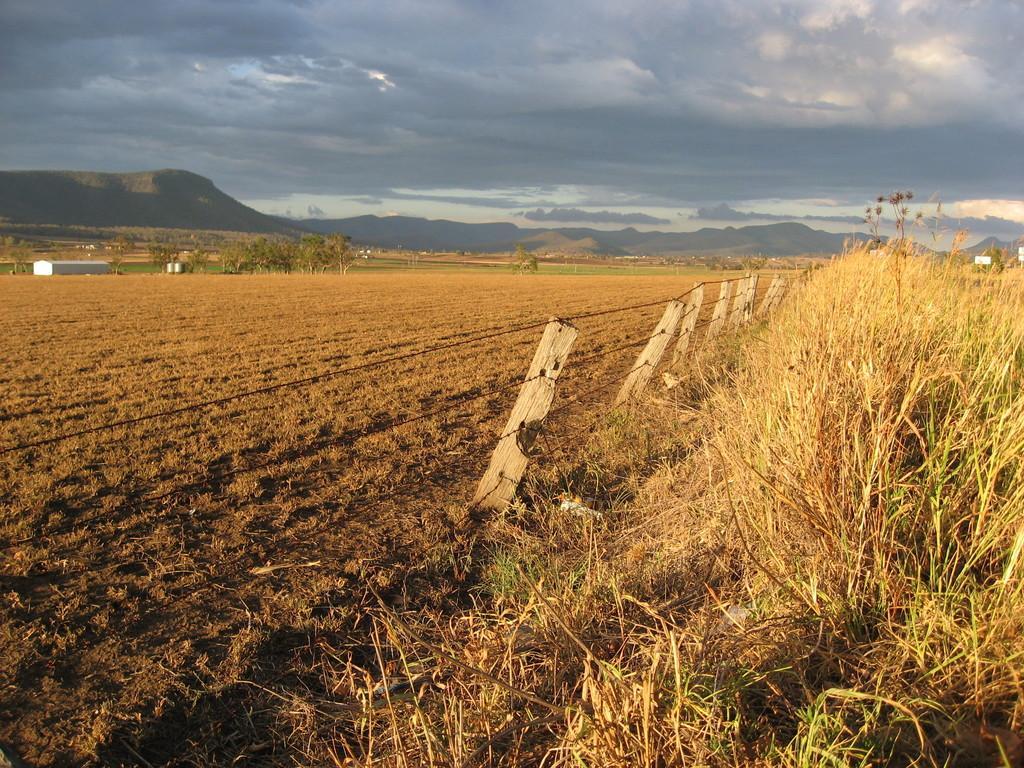How would you summarize this image in a sentence or two? In this picture we can see grass on the right side, there is a fencing here, we can see the sky at the top of the picture, we can see soil here, there are some trees here. 